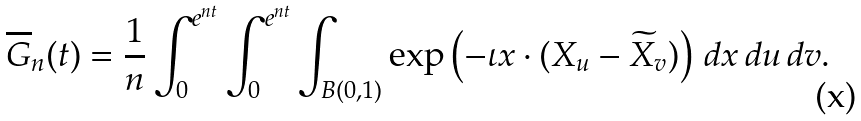<formula> <loc_0><loc_0><loc_500><loc_500>\overline { G } _ { n } ( t ) = \frac { 1 } { n } \int ^ { e ^ { n t } } _ { 0 } \int ^ { e ^ { n t } } _ { 0 } \int _ { B ( 0 , 1 ) } \exp \left ( - \iota x \cdot ( X _ { u } - \widetilde { X } _ { v } ) \right ) \, d x \, d u \, d v .</formula> 